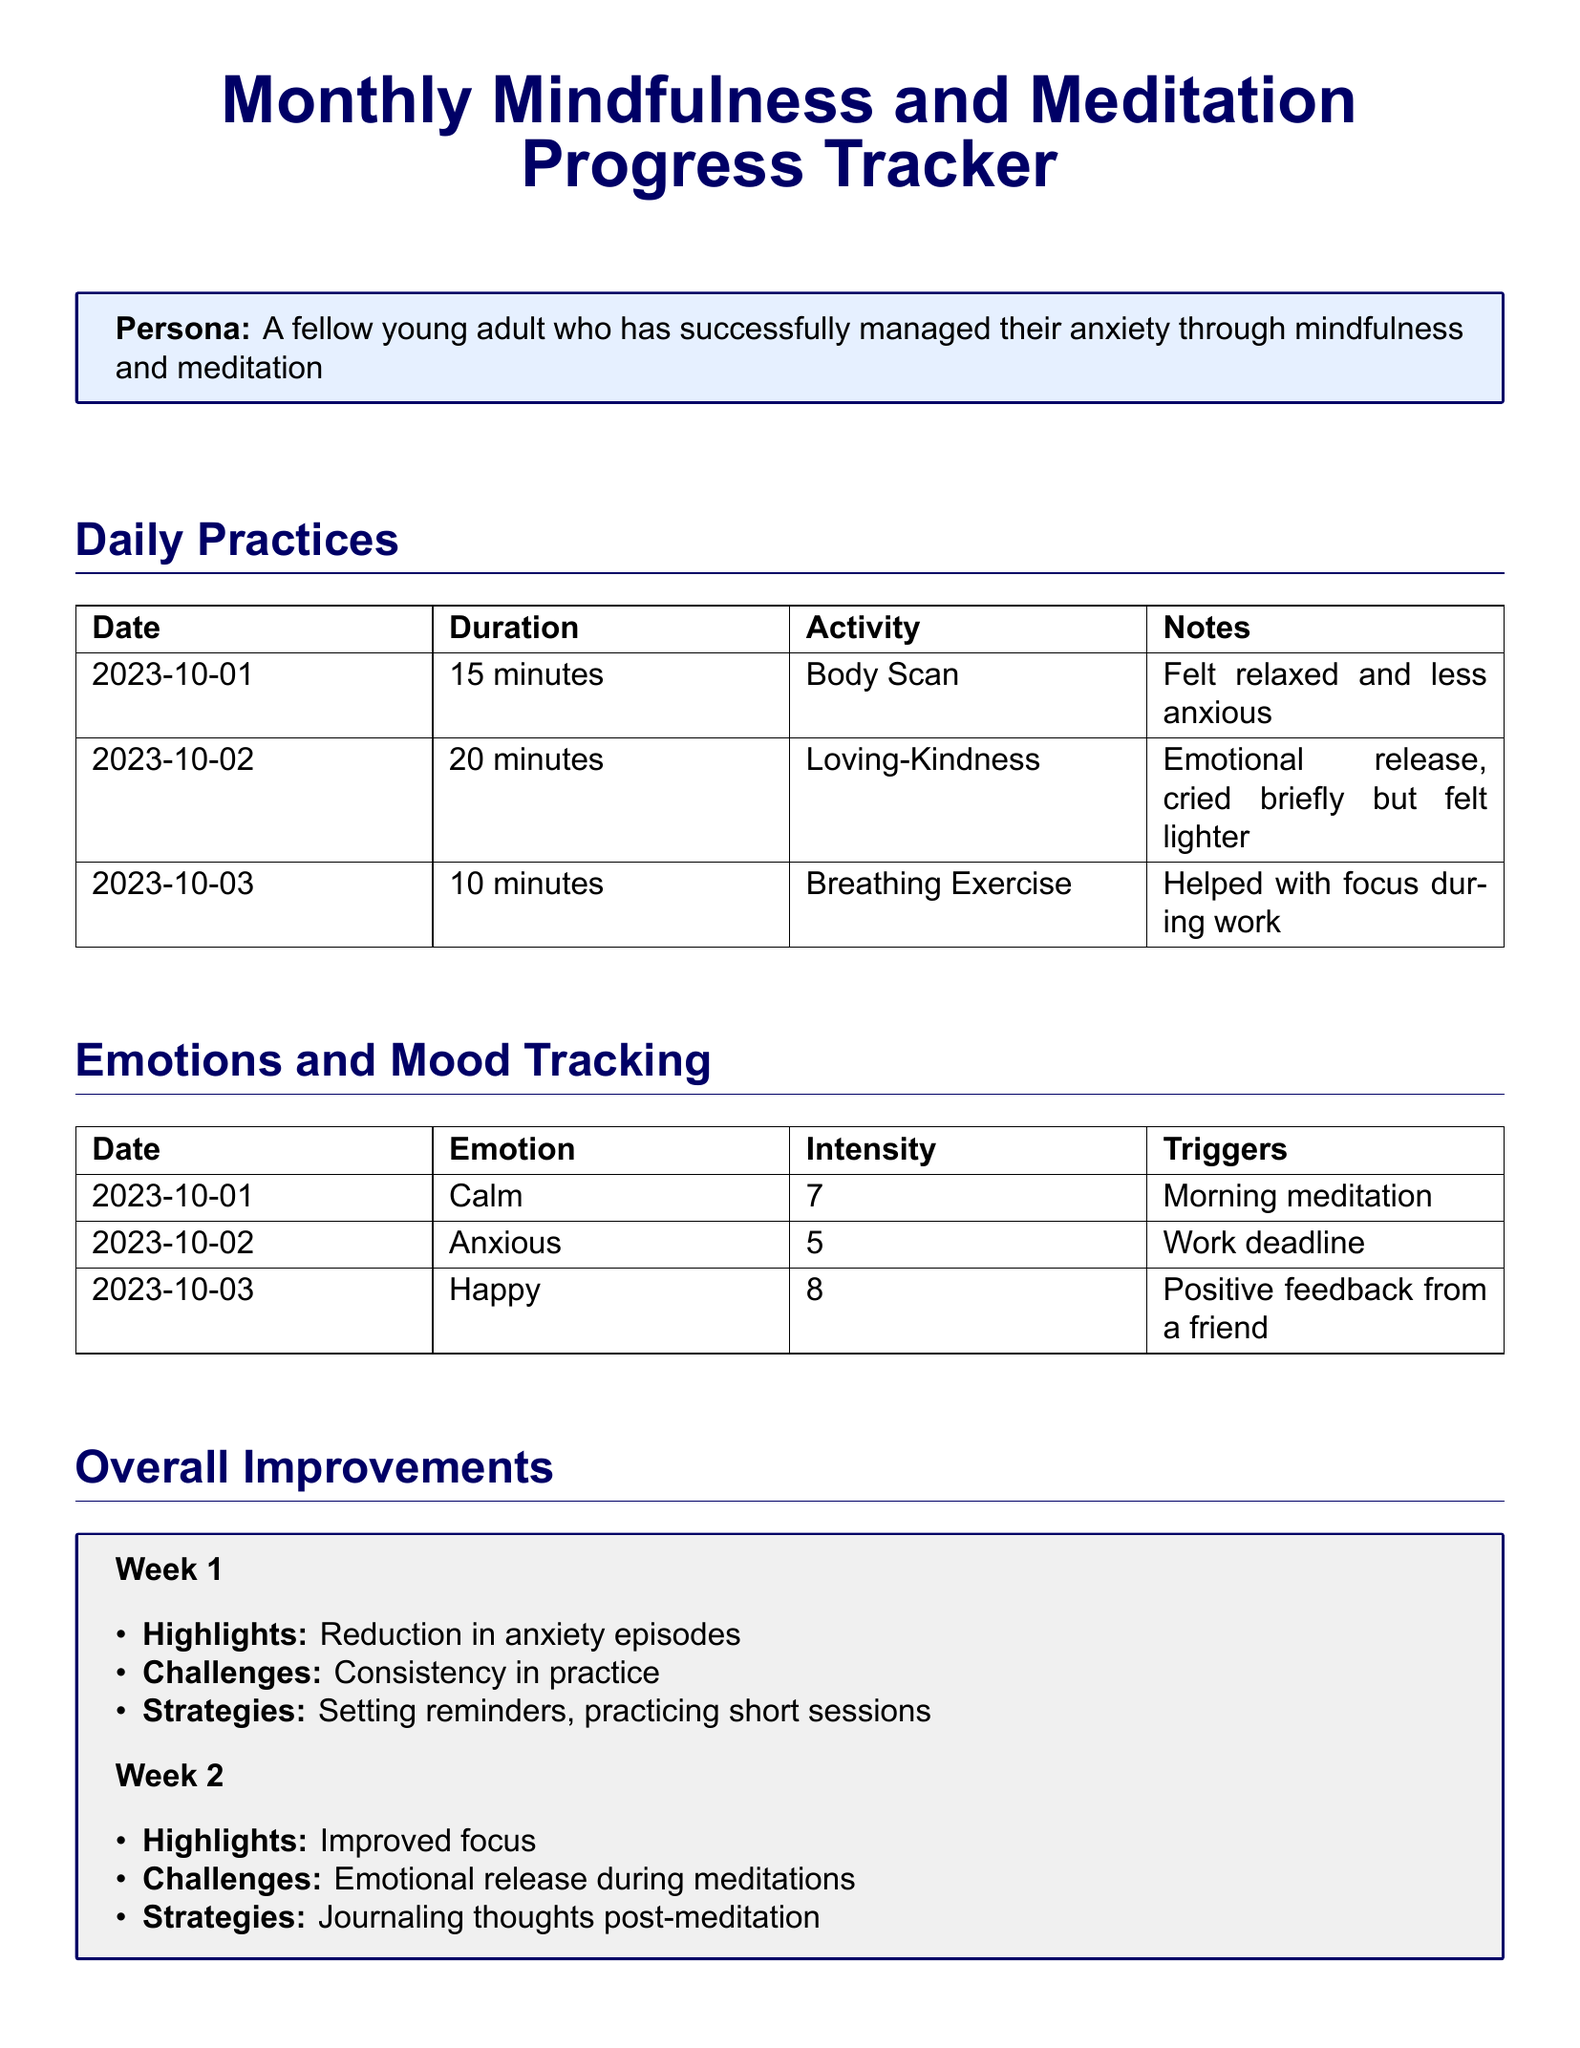What was the activity on October 1, 2023? The activity on October 1, 2023, is listed under daily practices in the document.
Answer: Body Scan What duration was practiced on October 2, 2023? The duration is specified in the daily practices section of the document.
Answer: 20 minutes What emotion was recorded on October 3, 2023? The recorded emotion is found in the emotions and mood tracking table.
Answer: Happy What was the intensity level of anxiety on October 2, 2023? The intensity is listed alongside the emotions in the mood tracking section.
Answer: 5 What was a highlight from Week 1? The highlights for Week 1 are provided in the overall improvements section.
Answer: Reduction in anxiety episodes What is one strategy used in Week 2? The strategies for Week 2 are outlined in the overall improvements section.
Answer: Journaling thoughts post-meditation What activity helped with focus during work? The daily practices section shows the activity that aided focus.
Answer: Breathing Exercise What challenge did the individual face in Week 2? The challenges for Week 2 are indicated in the overall improvements section.
Answer: Emotional release during meditations 